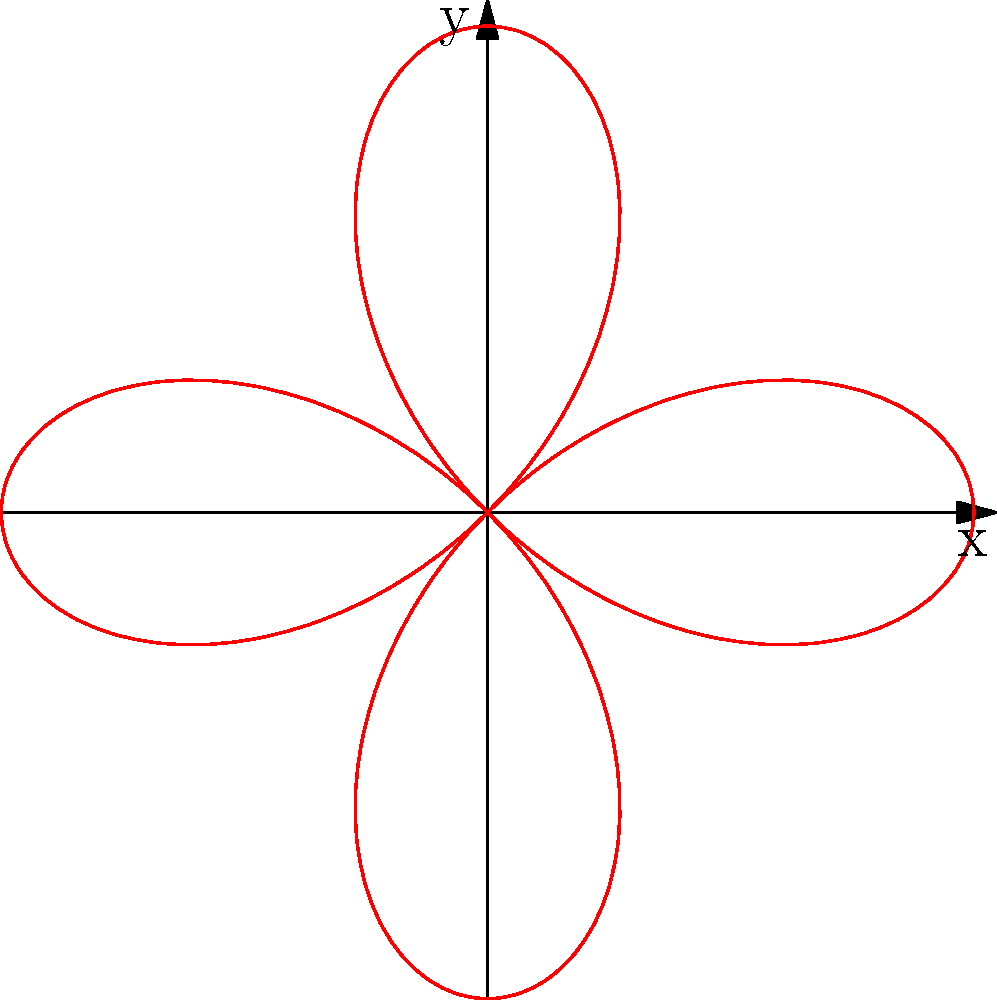Consider the polar curve given by the equation $r = 2\cos(2\theta)$. What type of symmetry does this curve exhibit? To determine the symmetry of the polar curve $r = 2\cos(2\theta)$, let's follow these steps:

1. Recall that a polar curve can have symmetry about the x-axis, y-axis, or origin.

2. To check for x-axis symmetry:
   Replace $\theta$ with $-\theta$: $r = 2\cos(2(-\theta)) = 2\cos(2\theta)$
   The equation remains unchanged, so the curve is symmetric about the x-axis.

3. To check for y-axis symmetry:
   Replace $\theta$ with $\pi - \theta$: $r = 2\cos(2(\pi - \theta)) = 2\cos(2\pi - 2\theta) = 2\cos(2\theta)$
   The equation remains unchanged, so the curve is also symmetric about the y-axis.

4. To check for origin symmetry:
   Replace $r$ with $-r$ and $\theta$ with $\theta + \pi$:
   $-r = 2\cos(2(\theta + \pi)) = 2\cos(2\theta + 2\pi) = 2\cos(2\theta)$
   This is equivalent to $r = -2\cos(2\theta)$, which is different from the original equation.
   Therefore, the curve does not have symmetry about the origin.

5. Looking at the graph, we can visually confirm that the curve has four symmetric lobes, two along the x-axis and two along the y-axis.

Thus, the curve exhibits both x-axis and y-axis symmetry, but not origin symmetry.
Answer: X-axis and Y-axis symmetry 